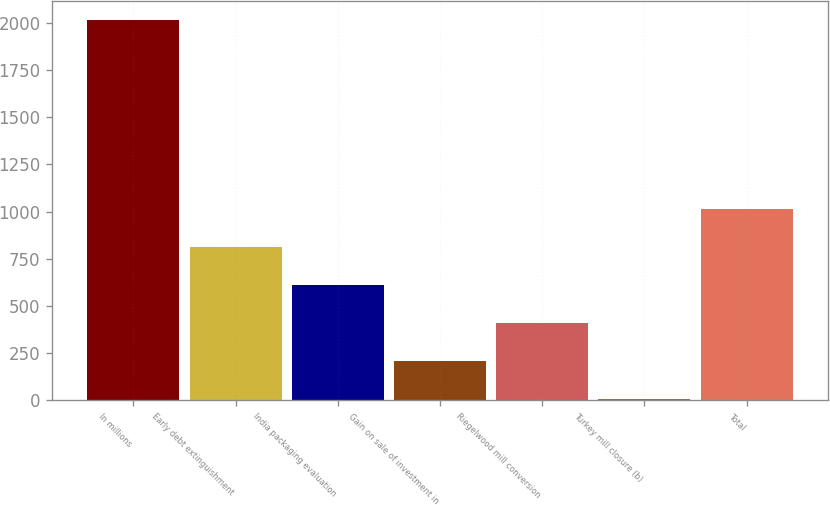Convert chart to OTSL. <chart><loc_0><loc_0><loc_500><loc_500><bar_chart><fcel>In millions<fcel>Early debt extinguishment<fcel>India packaging evaluation<fcel>Gain on sale of investment in<fcel>Riegelwood mill conversion<fcel>Turkey mill closure (b)<fcel>Total<nl><fcel>2016<fcel>810.6<fcel>609.7<fcel>207.9<fcel>408.8<fcel>7<fcel>1011.5<nl></chart> 